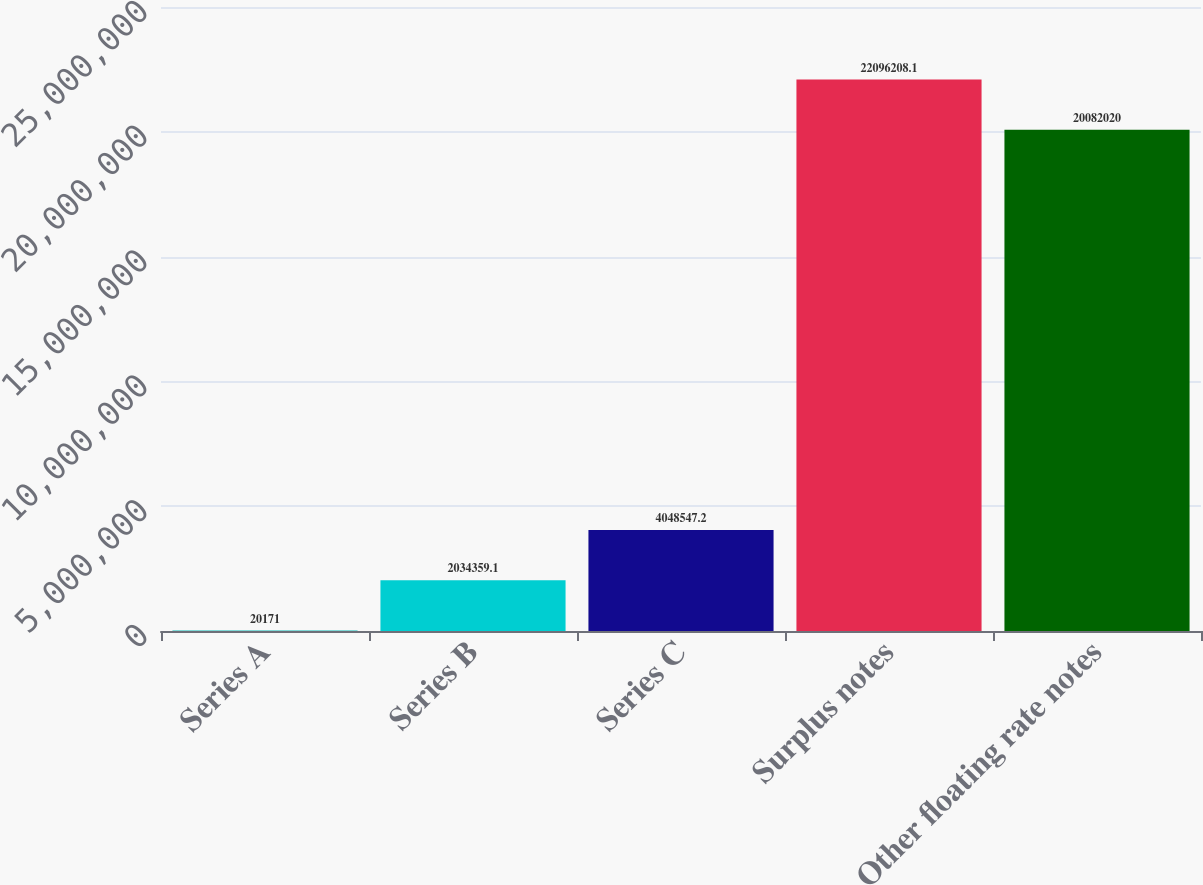Convert chart. <chart><loc_0><loc_0><loc_500><loc_500><bar_chart><fcel>Series A<fcel>Series B<fcel>Series C<fcel>Surplus notes<fcel>Other floating rate notes<nl><fcel>20171<fcel>2.03436e+06<fcel>4.04855e+06<fcel>2.20962e+07<fcel>2.0082e+07<nl></chart> 